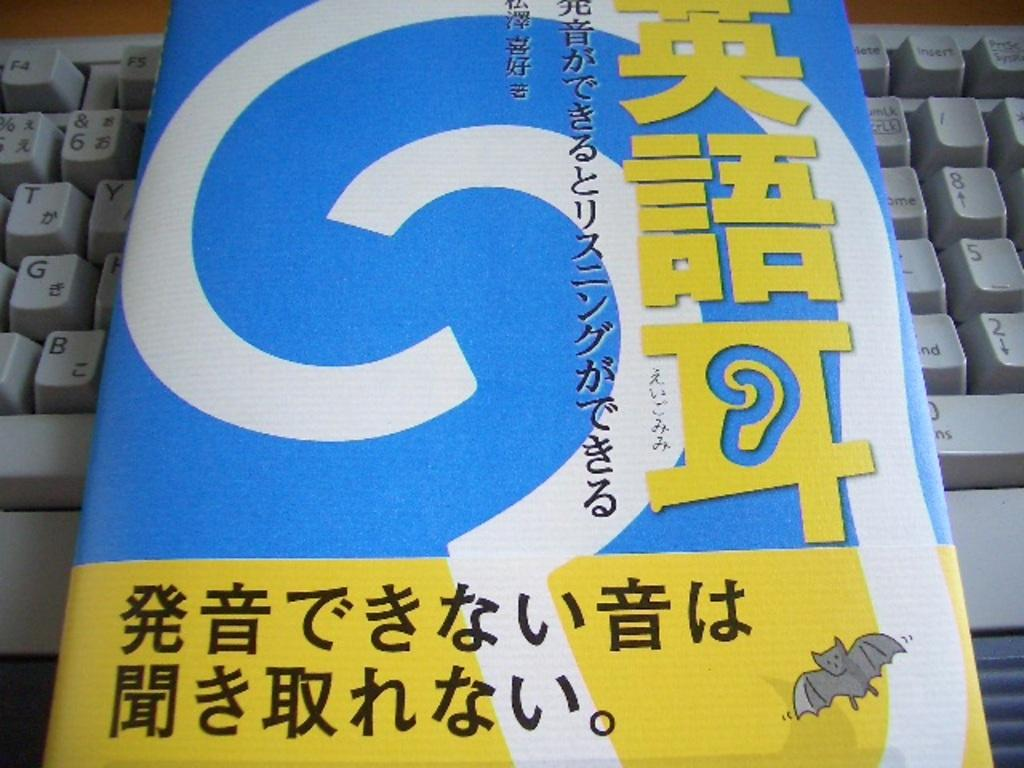Provide a one-sentence caption for the provided image. a book with Japanese letters on a keyboard with T and G keys. 